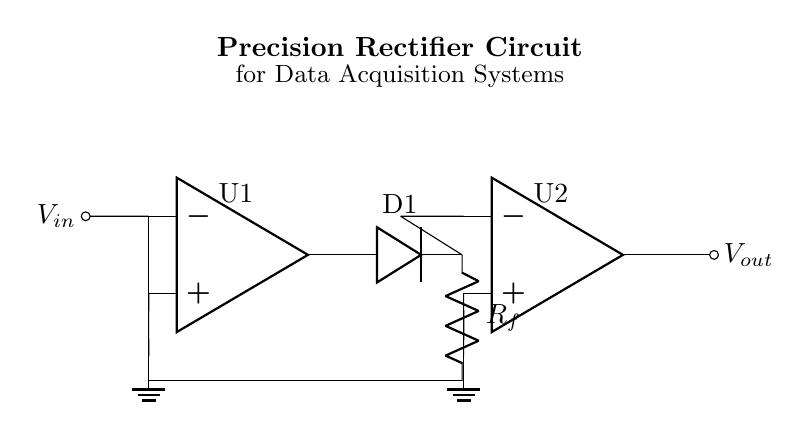What are the main active components in this circuit? The main active components are the two operational amplifiers represented as U1 and U2 in the diagram. Operational amplifiers are critical in signal processing, especially in a precision rectifier circuit.
Answer: operational amplifiers What type of rectifier is represented in the circuit? This circuit is a precision rectifier, also known as an active rectifier. It uses operational amplifiers in conjunction with diodes to achieve a more accurate rectification of the input signal compared to passive rectifiers.
Answer: precision rectifier What is the purpose of the diode in this circuit? The diode's purpose is to allow current to flow in only one direction, ensuring that the output voltage reflects the positive half-cycle of the input voltage while blocking the negative half-cycle.
Answer: allow unidirectional current flow How does the feedback resistor influence the circuit? The feedback resistor, labeled R_f in the diagram, controls the gain of the operational amplifier and affects how the output voltage responds to the input signal. It sets the level of amplification in the circuit, ensuring a precise rectification of the signal.
Answer: controls gain What happens to the output voltage when the input voltage is negative? When the input voltage is negative, the operational amplifier will output a voltage near zero since the diode is reverse biased and prevents current from flowing, effectively leaving the output at ground potential.
Answer: output near zero How many operational amplifiers are used in this precision rectifier circuit? There are two operational amplifiers in the circuit, labeled U1 and U2. Each op-amp serves a critical role in handling the input signal and generating the desired output voltage.
Answer: two What is the role of ground in this circuit? The ground acts as a reference point for the circuit. It sets the zero voltage level and is essential for defining the output voltage of the op-amps in relation to the input signal.
Answer: reference voltage level 